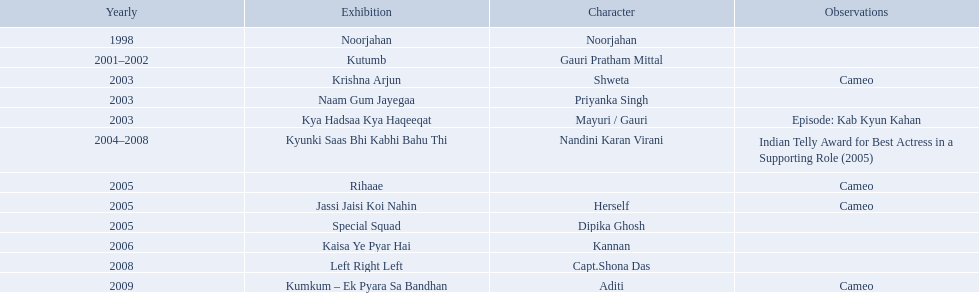On what shows did gauri pradhan tejwani appear after 2000? Kutumb, Krishna Arjun, Naam Gum Jayegaa, Kya Hadsaa Kya Haqeeqat, Kyunki Saas Bhi Kabhi Bahu Thi, Rihaae, Jassi Jaisi Koi Nahin, Special Squad, Kaisa Ye Pyar Hai, Left Right Left, Kumkum – Ek Pyara Sa Bandhan. In which of them was is a cameo appearance? Krishna Arjun, Rihaae, Jassi Jaisi Koi Nahin, Kumkum – Ek Pyara Sa Bandhan. Of these which one did she play the role of herself? Jassi Jaisi Koi Nahin. What are all of the shows? Noorjahan, Kutumb, Krishna Arjun, Naam Gum Jayegaa, Kya Hadsaa Kya Haqeeqat, Kyunki Saas Bhi Kabhi Bahu Thi, Rihaae, Jassi Jaisi Koi Nahin, Special Squad, Kaisa Ye Pyar Hai, Left Right Left, Kumkum – Ek Pyara Sa Bandhan. When were they in production? 1998, 2001–2002, 2003, 2003, 2003, 2004–2008, 2005, 2005, 2005, 2006, 2008, 2009. And which show was he on for the longest time? Kyunki Saas Bhi Kabhi Bahu Thi. In 1998 what was the role of gauri pradhan tejwani? Noorjahan. In 2003 what show did gauri have a cameo in? Krishna Arjun. Gauri was apart of which television show for the longest? Kyunki Saas Bhi Kabhi Bahu Thi. What shows has gauri pradhan tejwani been in? Noorjahan, Kutumb, Krishna Arjun, Naam Gum Jayegaa, Kya Hadsaa Kya Haqeeqat, Kyunki Saas Bhi Kabhi Bahu Thi, Rihaae, Jassi Jaisi Koi Nahin, Special Squad, Kaisa Ye Pyar Hai, Left Right Left, Kumkum – Ek Pyara Sa Bandhan. Of these shows, which one lasted for more than a year? Kutumb, Kyunki Saas Bhi Kabhi Bahu Thi. Which of these lasted the longest? Kyunki Saas Bhi Kabhi Bahu Thi. 